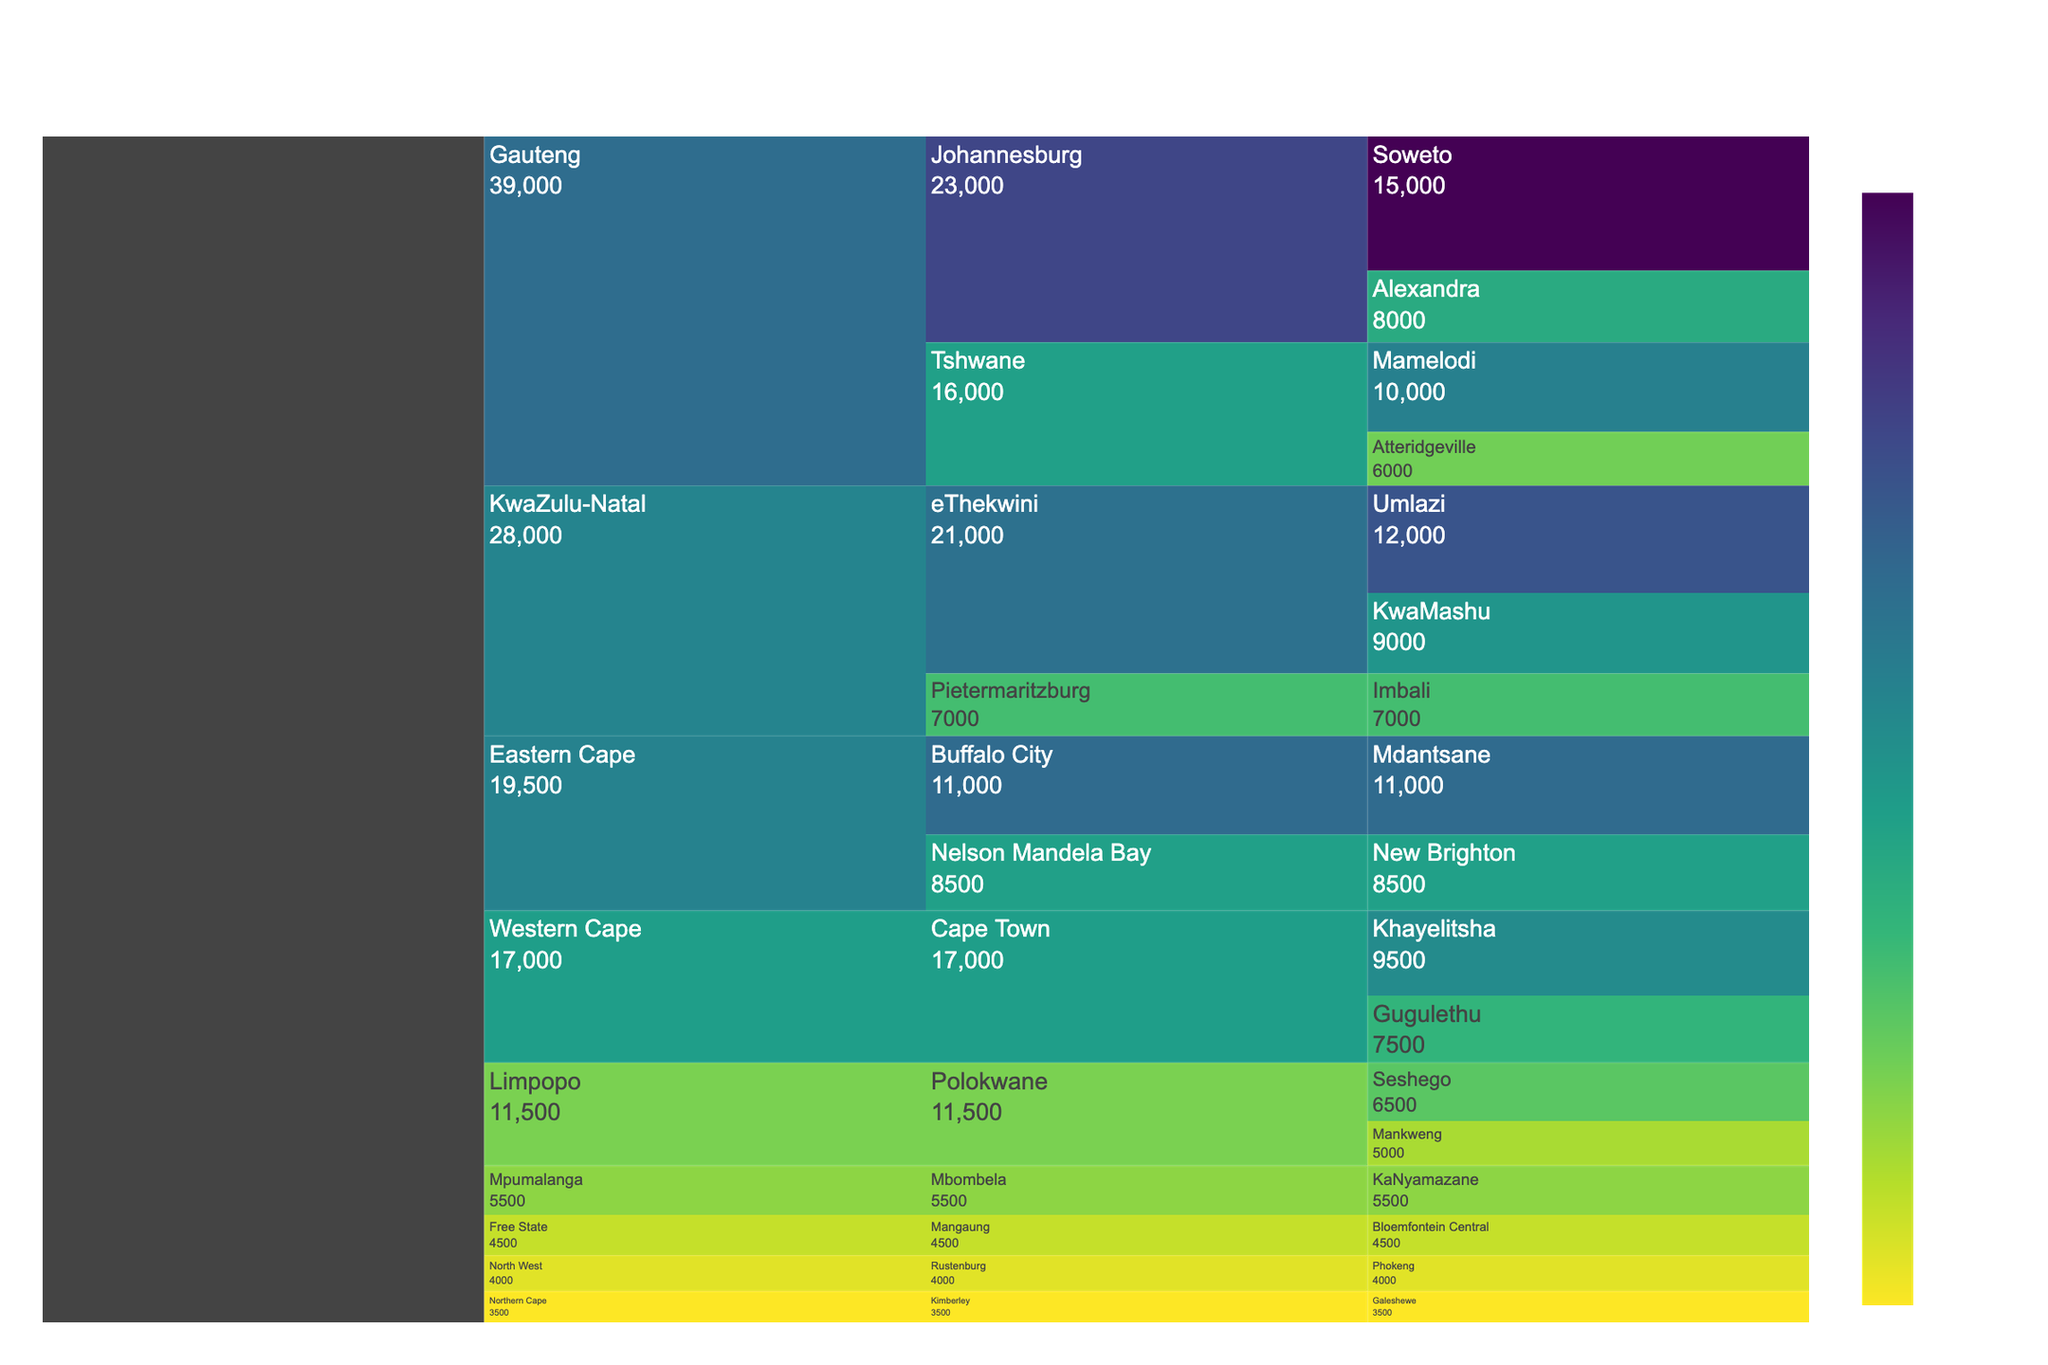What is the title of the figure? The title of the figure is displayed at the top. It helps to understand the main subject of the chart.
Answer: ANC Party Membership Distribution Which province has the highest total membership? Sum the membership values for each province and compare them to find the highest. Gauteng: 39000, KwaZulu-Natal: 28000, Eastern Cape: 19500, Western Cape: 17000, Limpopo: 11500, Free State: 4500, Mpumalanga: 5500, North West: 4000, Northern Cape: 3500.
Answer: Gauteng How many local branches are shown in Gauteng province? Count the number of local branches under the Gauteng province.
Answer: 4 What is the difference in membership between the Soweto and Khayelitsha branches? Subtract the membership of Khayelitsha from that of Soweto. Soweto: 15000, Khayelitsha: 9500. 15000 - 9500.
Answer: 5500 Which region in KwaZulu-Natal has the highest membership? Compare the membership values of regions within KwaZulu-Natal. eThekwini (Umlazi + KwaMashu): 21000, Pietermaritzburg (Imbali): 7000.
Answer: eThekwini Between the eThekwini region and the Buffalo City region, which one has fewer members? Sum the membership values within the eThekwini and Buffalo City regions and compare. eThekwini (Umlazi + KwaMashu): 21000, Buffalo City (Mdantsane): 11000.
Answer: Buffalo City What is the total membership in the Eastern Cape province? Sum the membership values of all local branches in the Eastern Cape. Mdantsane: 11000, New Brighton: 8500. 11000 + 8500.
Answer: 19500 Which local branch has the smallest membership? Identify the branch with the smallest membership by comparing values.
Answer: Galeshewe How does the membership of the Imbali branch compare to the Mamelodi branch? Compare the membership values of the Imbali and Mamelodi branches. Imbali: 7000, Mamelodi: 10000.
Answer: Mamelodi has a higher membership Which province has the same number of regions shown in the figure as the Western Cape? Count the number of regions per province and compare with Western Cape. Western Cape: 1 (Cape Town). Gauteng: 2, KwaZulu-Natal: 2, Eastern Cape: 2, Limpopo: 1, Free State: 1, Mpumalanga: 1, North West: 1, Northern Cape: 1.
Answer: Limpopo, Free State, Mpumalanga, North West, Northern Cape 